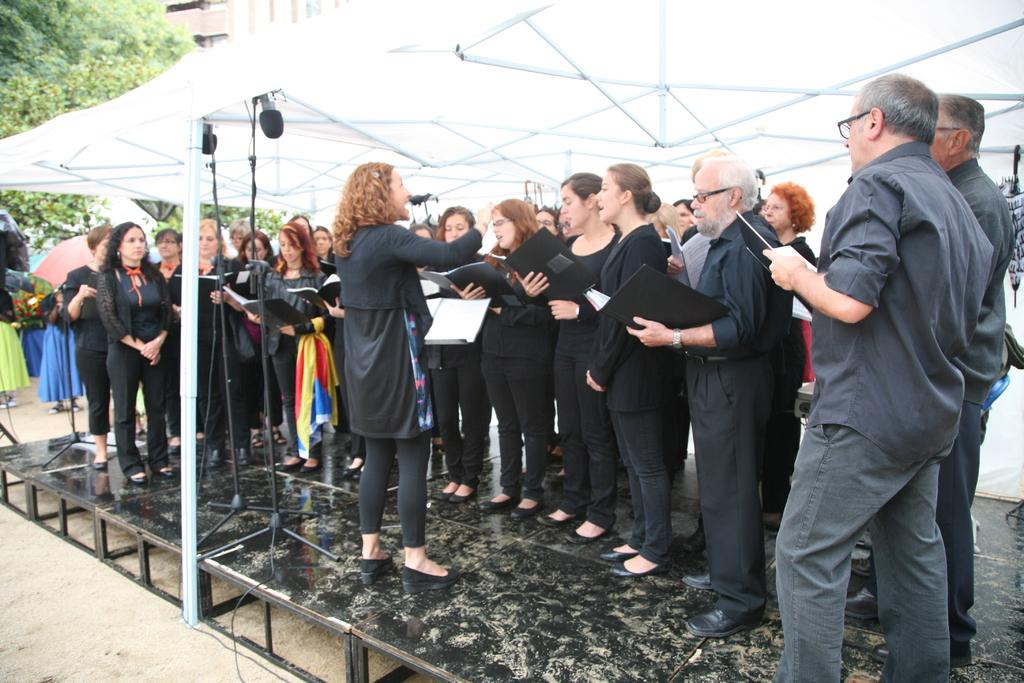What are the people on stage doing in the image? The people on stage are singing. What color are the dresses worn by the people on stage? The people on stage are wearing black dresses. What can be seen in the background of the image? There is a white tent, other people, a tree, and a building visible in the background. Can you see any rabbits hopping around in the image? No, there are no rabbits present in the image. What message of hope can be seen in the lyrics of the song being sung by the people on stage? The image does not provide any information about the lyrics of the song being sung, so we cannot determine the message of hope from the image. 